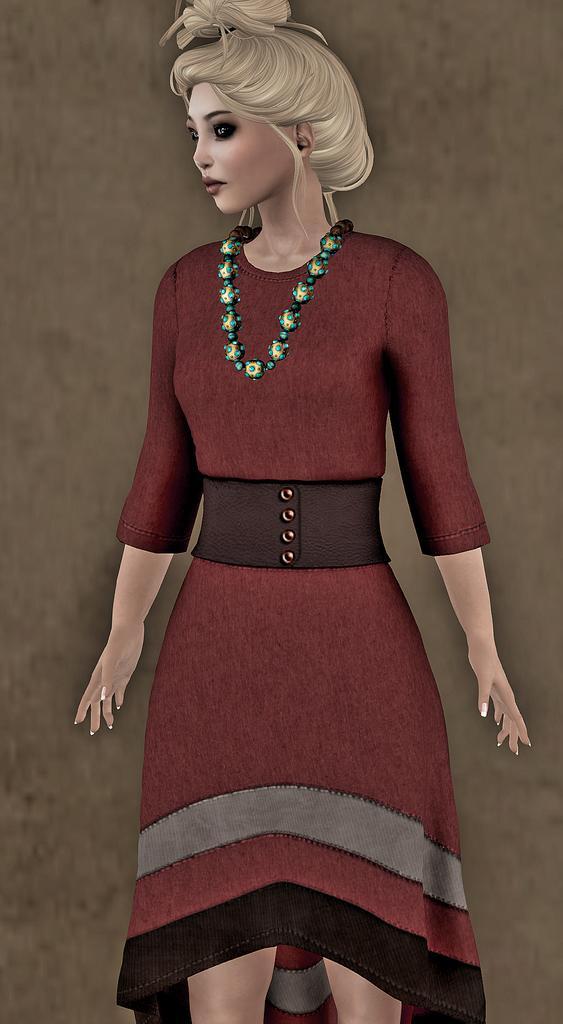Describe this image in one or two sentences. This is an animation picture. In this image there is a woman with red dress is stunning. At the back there is a brown color background. 